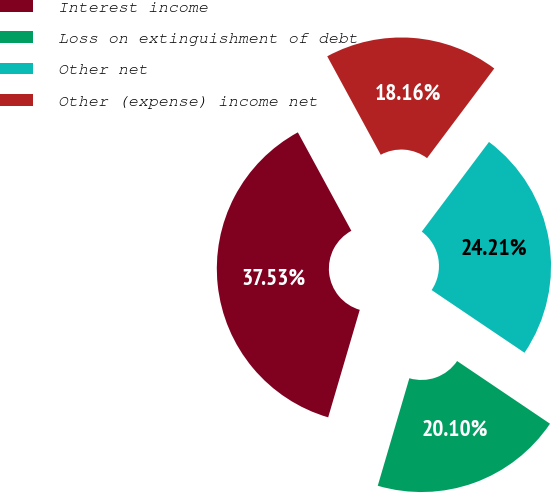Convert chart to OTSL. <chart><loc_0><loc_0><loc_500><loc_500><pie_chart><fcel>Interest income<fcel>Loss on extinguishment of debt<fcel>Other net<fcel>Other (expense) income net<nl><fcel>37.53%<fcel>20.1%<fcel>24.21%<fcel>18.16%<nl></chart> 